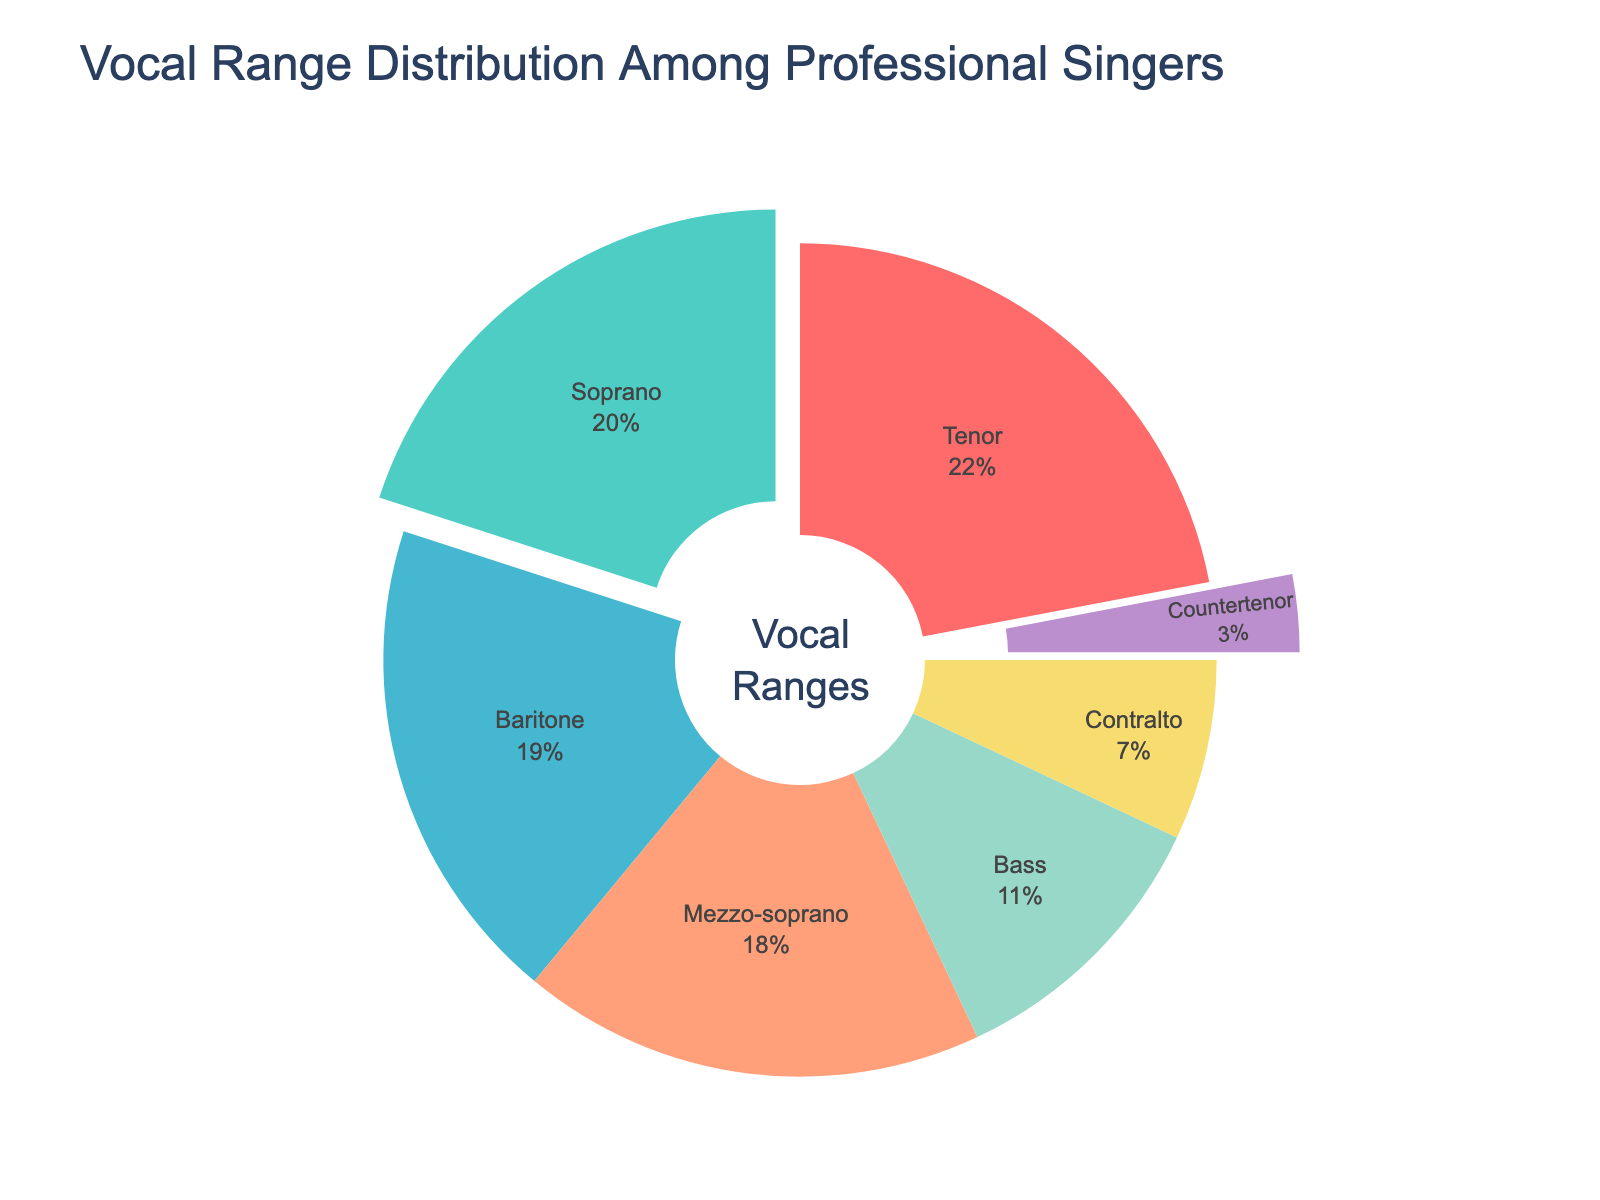What is the most common vocal range among professional singers? The pie chart shows that the tenor range makes up the largest percentage of singers.
Answer: Tenor Which vocal range has a larger percentage of singers, soprano or baritone? By comparing the wedges, soprano has 20% while baritone has 19%.
Answer: Soprano If you combine the percentages of mezzo-soprano, contralto, and countertenor, what is their total percentage? Summing the percentages of mezzo-soprano (18%), contralto (7%), and countertenor (3%) yields 18 + 7 + 3 = 28%.
Answer: 28% Among the singers represented, which two vocal ranges together make up more than 40% of the singers? Tenor (22%) and baritone (19%) together make 22 + 19 = 41%, which is more than 40%.
Answer: Tenor and Baritone How much larger is the percentage of tenor singers compared to countertenor singers? The difference is calculated by subtracting the countertenor percentage (3%) from the tenor percentage (22%), resulting in 22 - 3 = 19%.
Answer: 19% What color represents the bass vocal range in the pie chart? The pie chart uses a distinct color for each vocal range, with bass represented by purple.
Answer: Purple If we combine all bass-voice categories (baritone and bass), do they exceed the percentage of soprano singers? Adding baritone (19%) and bass (11%) yields 19 + 11 = 30%, which is greater than soprano at 20%.
Answer: Yes Which vocal range is represented with the smallest percentage of singers, and by how much does it differ from the next smallest range? Countertenor is the smallest at 3%. The next smallest, contralto, is 7%, leading to a difference of 7 - 3 = 4%.
Answer: Countertenor, 4% What is the combined total percentage of singers in the bass and tenor ranges? Summing bass (11%) and tenor (22%) results in 11 + 22 = 33%.
Answer: 33% Is the percentage of soprano singers more than double the percentage of contralto singers? The percentage for soprano is 20%, and for contralto, it is 7%. Since 20 is more than double 7 (2 x 7 = 14), the answer is yes.
Answer: Yes 